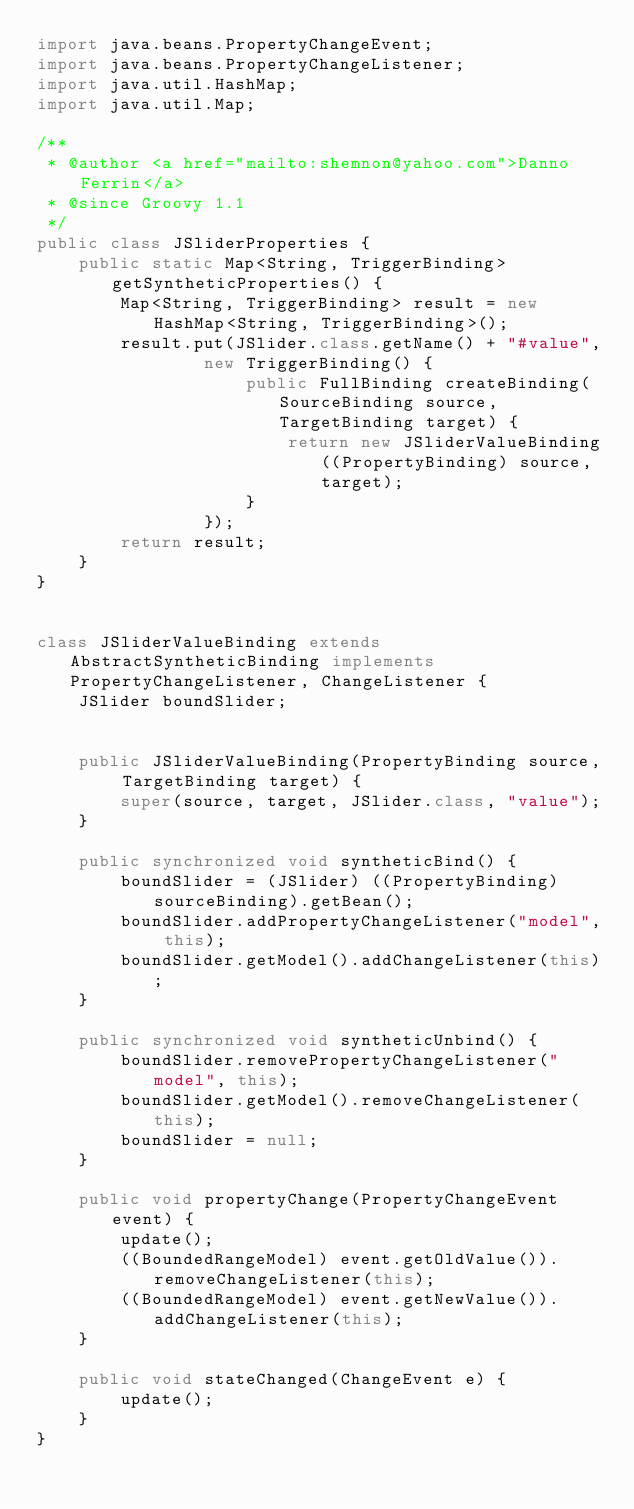Convert code to text. <code><loc_0><loc_0><loc_500><loc_500><_Java_>import java.beans.PropertyChangeEvent;
import java.beans.PropertyChangeListener;
import java.util.HashMap;
import java.util.Map;

/**
 * @author <a href="mailto:shemnon@yahoo.com">Danno Ferrin</a>
 * @since Groovy 1.1
 */
public class JSliderProperties {
    public static Map<String, TriggerBinding> getSyntheticProperties() {
        Map<String, TriggerBinding> result = new HashMap<String, TriggerBinding>();
        result.put(JSlider.class.getName() + "#value",
                new TriggerBinding() {
                    public FullBinding createBinding(SourceBinding source, TargetBinding target) {
                        return new JSliderValueBinding((PropertyBinding) source, target);
                    }
                });
        return result;
    }
}


class JSliderValueBinding extends AbstractSyntheticBinding implements PropertyChangeListener, ChangeListener {
    JSlider boundSlider;


    public JSliderValueBinding(PropertyBinding source, TargetBinding target) {
        super(source, target, JSlider.class, "value");
    }

    public synchronized void syntheticBind() {
        boundSlider = (JSlider) ((PropertyBinding)sourceBinding).getBean();
        boundSlider.addPropertyChangeListener("model", this);
        boundSlider.getModel().addChangeListener(this);
    }

    public synchronized void syntheticUnbind() {
        boundSlider.removePropertyChangeListener("model", this);
        boundSlider.getModel().removeChangeListener(this);
        boundSlider = null;
    }

    public void propertyChange(PropertyChangeEvent event) {
        update();
        ((BoundedRangeModel) event.getOldValue()).removeChangeListener(this);
        ((BoundedRangeModel) event.getNewValue()).addChangeListener(this);
    }

    public void stateChanged(ChangeEvent e) {
        update();
    }
}
</code> 